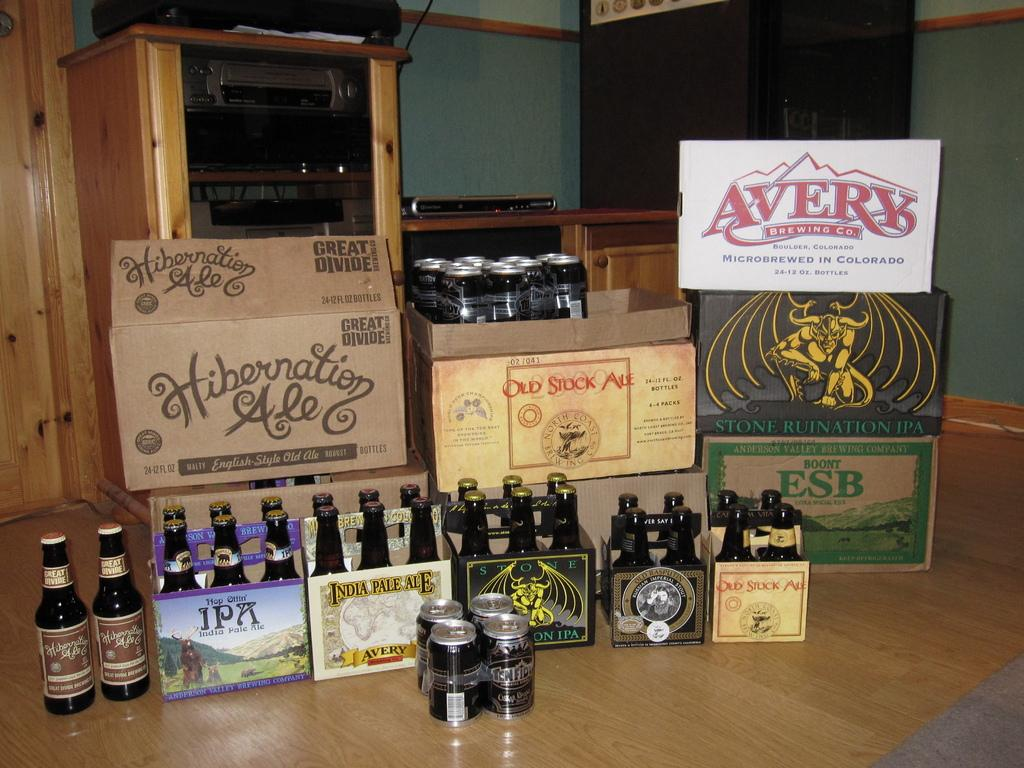<image>
Describe the image concisely. A box of Hibernation Ale sits with other beer boxes and bottles. 